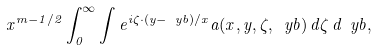<formula> <loc_0><loc_0><loc_500><loc_500>x ^ { m - 1 / 2 } \int _ { 0 } ^ { \infty } \int e ^ { i \zeta \cdot ( y - \ y b ) / x } a ( x , y , \zeta , \ y b ) \, d \zeta \, d \ y b ,</formula> 